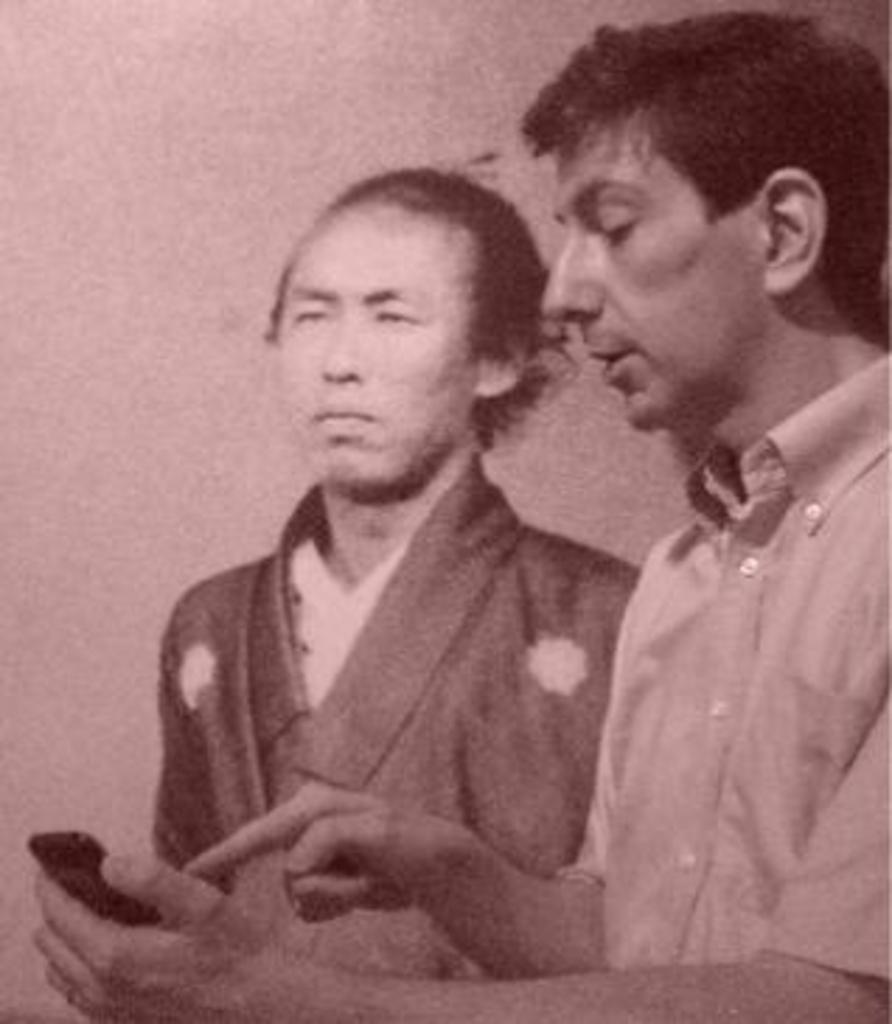Describe this image in one or two sentences. In this picture I can see two persons and right hand side person holding a mobile and pointing the phone with his finger. 